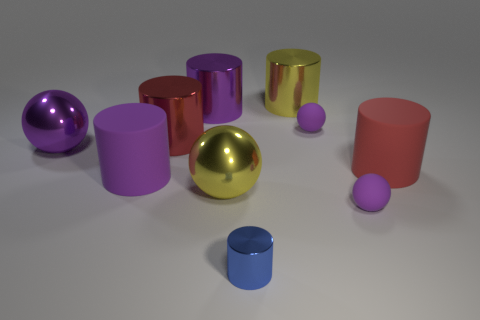Are there more yellow metallic things that are to the right of the tiny blue shiny cylinder than gray metal things? Upon close observation of the image, it appears that there is only one yellow metallic object to the right of the tiny blue cylinder, and there are no gray metallic objects in sight at all. So yes, there are more yellow metallic things to the right of the blue cylinder—specifically, one more—since there aren't any gray metal things present for comparison. 